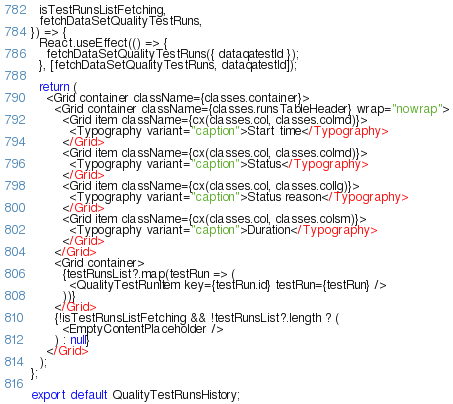<code> <loc_0><loc_0><loc_500><loc_500><_TypeScript_>  isTestRunsListFetching,
  fetchDataSetQualityTestRuns,
}) => {
  React.useEffect(() => {
    fetchDataSetQualityTestRuns({ dataqatestId });
  }, [fetchDataSetQualityTestRuns, dataqatestId]);

  return (
    <Grid container className={classes.container}>
      <Grid container className={classes.runsTableHeader} wrap="nowrap">
        <Grid item className={cx(classes.col, classes.colmd)}>
          <Typography variant="caption">Start time</Typography>
        </Grid>
        <Grid item className={cx(classes.col, classes.colmd)}>
          <Typography variant="caption">Status</Typography>
        </Grid>
        <Grid item className={cx(classes.col, classes.collg)}>
          <Typography variant="caption">Status reason</Typography>
        </Grid>
        <Grid item className={cx(classes.col, classes.colsm)}>
          <Typography variant="caption">Duration</Typography>
        </Grid>
      </Grid>
      <Grid container>
        {testRunsList?.map(testRun => (
          <QualityTestRunItem key={testRun.id} testRun={testRun} />
        ))}
      </Grid>
      {!isTestRunsListFetching && !testRunsList?.length ? (
        <EmptyContentPlaceholder />
      ) : null}
    </Grid>
  );
};

export default QualityTestRunsHistory;
</code> 